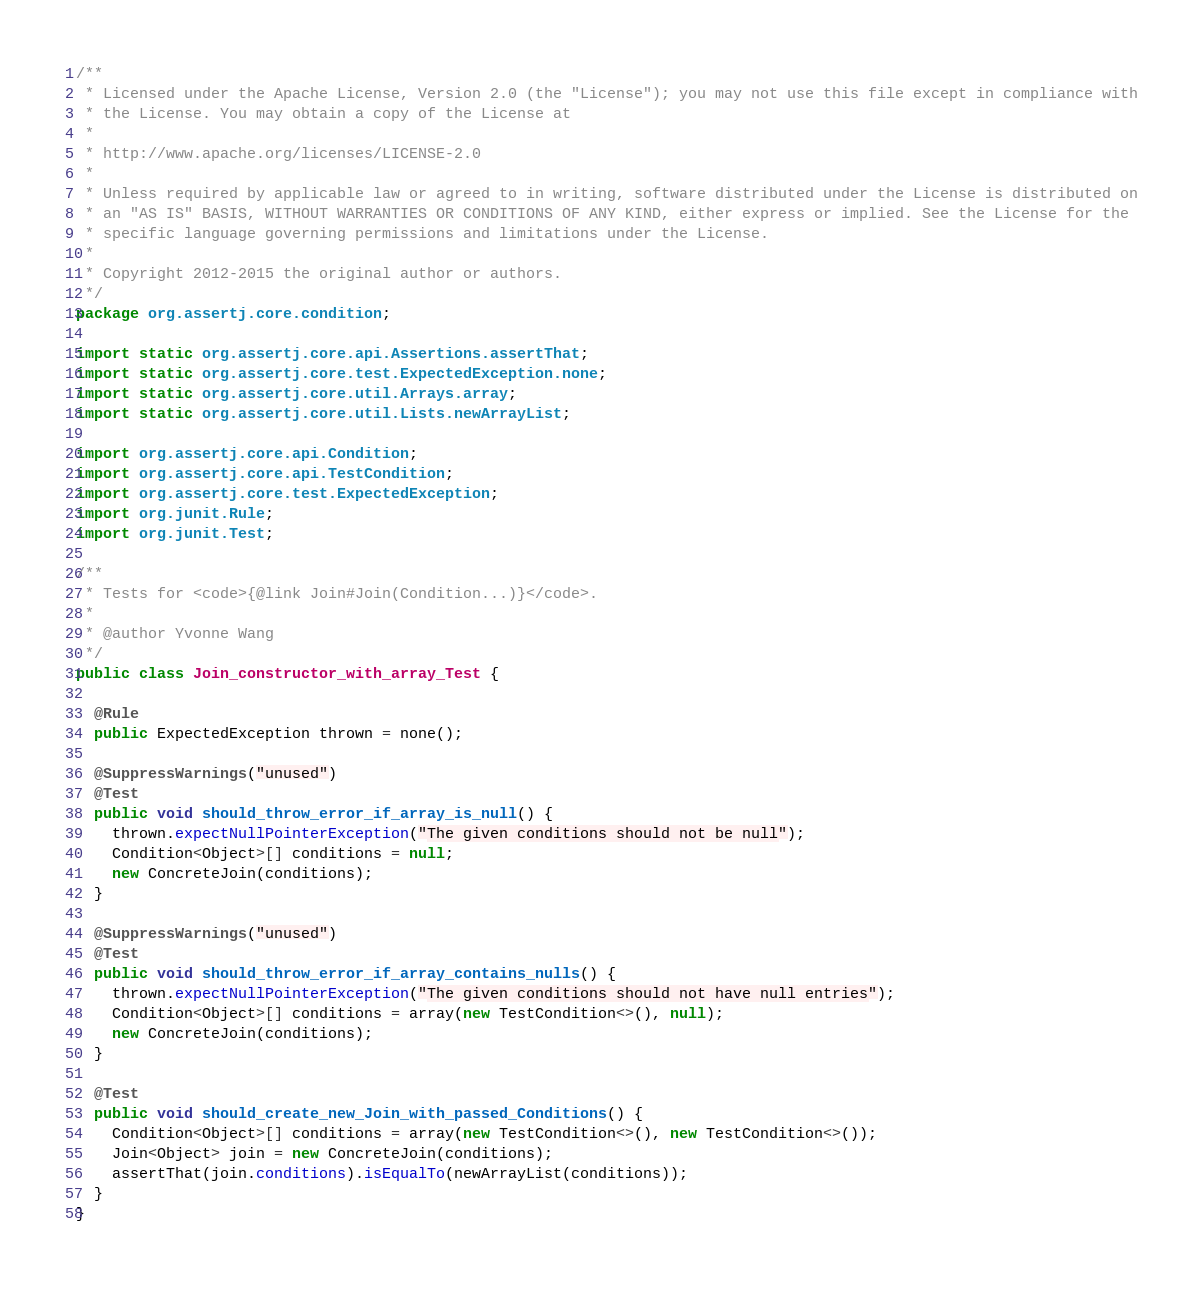<code> <loc_0><loc_0><loc_500><loc_500><_Java_>/**
 * Licensed under the Apache License, Version 2.0 (the "License"); you may not use this file except in compliance with
 * the License. You may obtain a copy of the License at
 *
 * http://www.apache.org/licenses/LICENSE-2.0
 *
 * Unless required by applicable law or agreed to in writing, software distributed under the License is distributed on
 * an "AS IS" BASIS, WITHOUT WARRANTIES OR CONDITIONS OF ANY KIND, either express or implied. See the License for the
 * specific language governing permissions and limitations under the License.
 *
 * Copyright 2012-2015 the original author or authors.
 */
package org.assertj.core.condition;

import static org.assertj.core.api.Assertions.assertThat;
import static org.assertj.core.test.ExpectedException.none;
import static org.assertj.core.util.Arrays.array;
import static org.assertj.core.util.Lists.newArrayList;

import org.assertj.core.api.Condition;
import org.assertj.core.api.TestCondition;
import org.assertj.core.test.ExpectedException;
import org.junit.Rule;
import org.junit.Test;

/**
 * Tests for <code>{@link Join#Join(Condition...)}</code>.
 * 
 * @author Yvonne Wang
 */
public class Join_constructor_with_array_Test {

  @Rule
  public ExpectedException thrown = none();

  @SuppressWarnings("unused")
  @Test
  public void should_throw_error_if_array_is_null() {
    thrown.expectNullPointerException("The given conditions should not be null");
    Condition<Object>[] conditions = null;
    new ConcreteJoin(conditions);
  }

  @SuppressWarnings("unused")
  @Test
  public void should_throw_error_if_array_contains_nulls() {
    thrown.expectNullPointerException("The given conditions should not have null entries");
    Condition<Object>[] conditions = array(new TestCondition<>(), null);
    new ConcreteJoin(conditions);
  }

  @Test
  public void should_create_new_Join_with_passed_Conditions() {
    Condition<Object>[] conditions = array(new TestCondition<>(), new TestCondition<>());
    Join<Object> join = new ConcreteJoin(conditions);
    assertThat(join.conditions).isEqualTo(newArrayList(conditions));
  }
}
</code> 